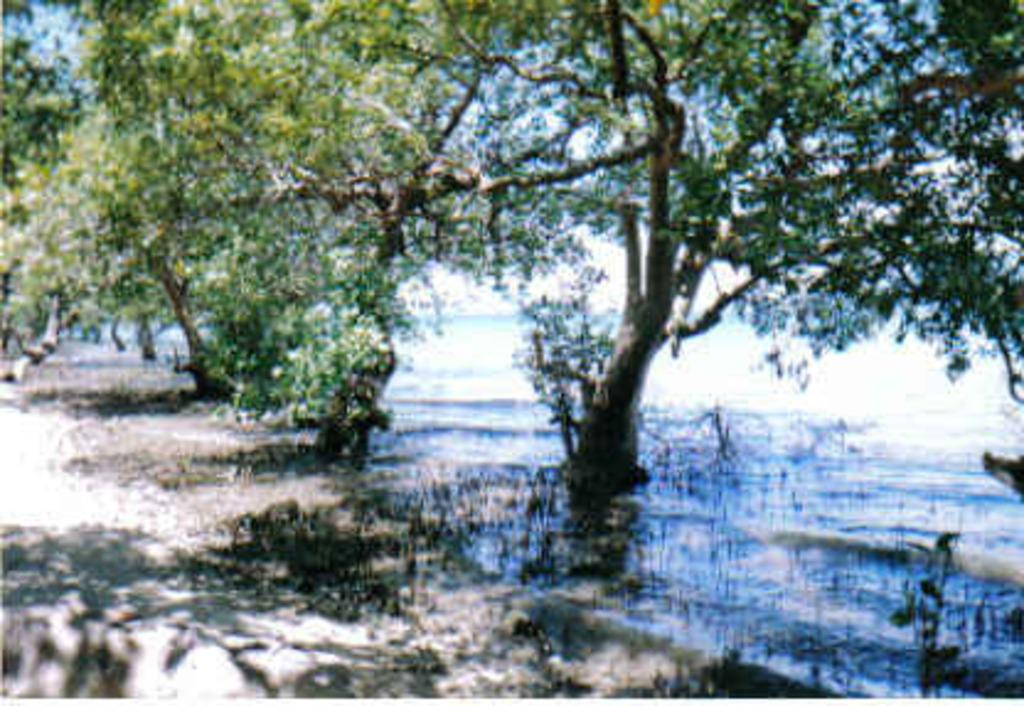What objects are on the ground in the image? There are planets on the ground in the image. What type of natural vegetation is present in the image? There are trees in the image. What can be seen in the image besides the planets and trees? Water is visible in the image. What is visible in the background of the image? The sky is visible in the background of the image. What is the weight of the building in the image? There is no building present in the image; it features planets on the ground, trees, water, and the sky. 